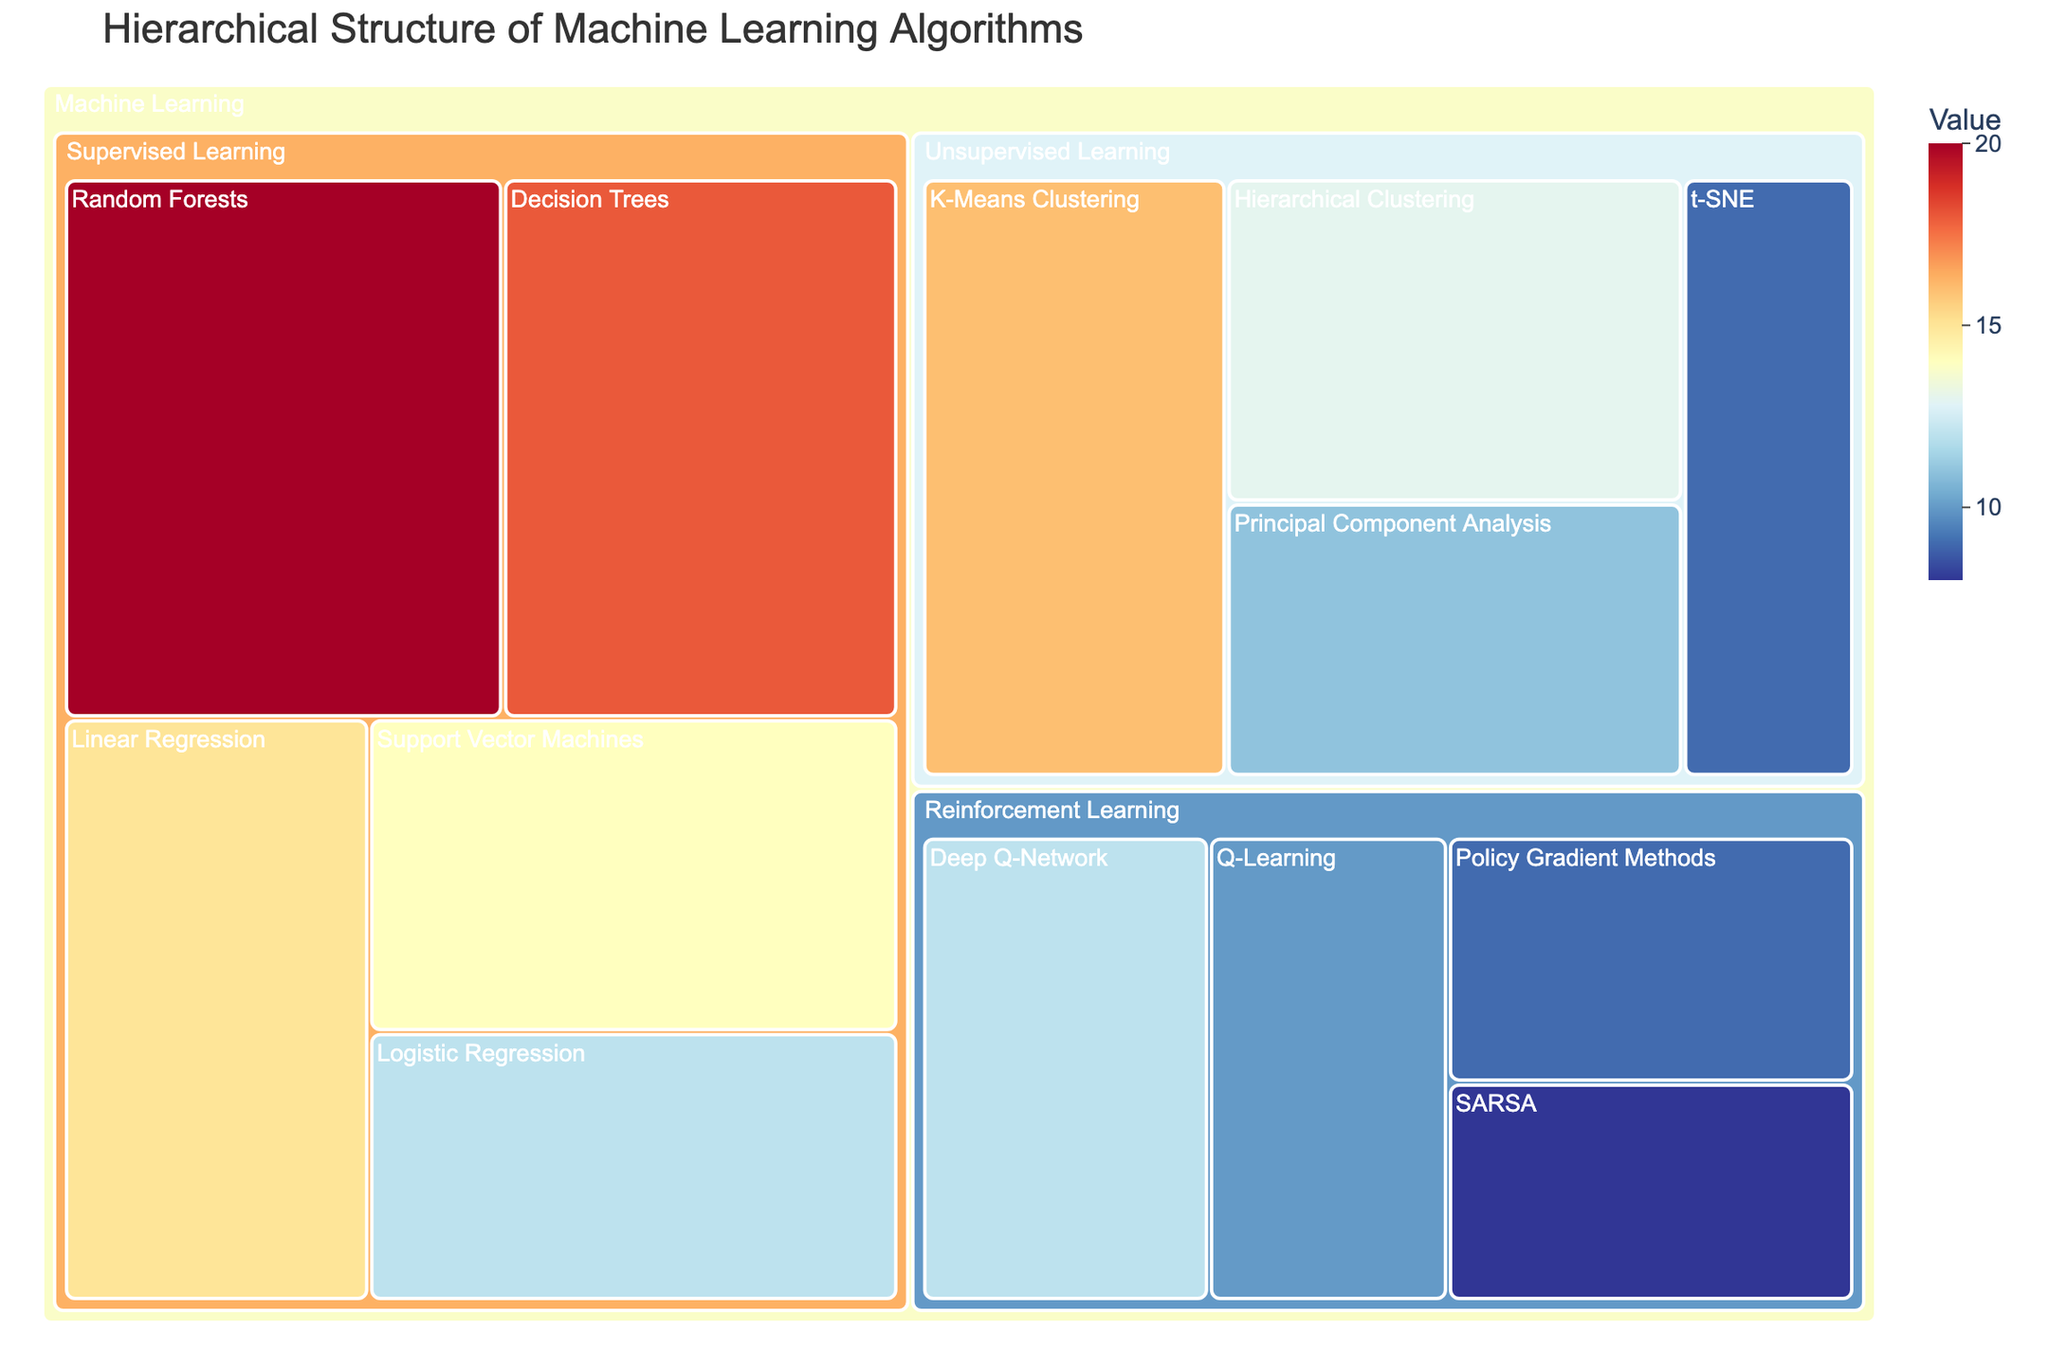what is the title of the treemap? The title is usually positioned at the top center of the plot and summarizes the data being visualized. In this case, the title is given in the code.
Answer: Hierarchical Structure of Machine Learning Algorithms How many algorithms are there in the Supervised Learning category? In the treemap, we can count the number of blocks within the Supervised Learning subcategory under Machine Learning. Each block represents an algorithm.
Answer: 5 Which subcategory has the algorithm with the highest value? To determine the highest value, we look for the largest block or the block with the highest value in the treemap and identify its parent subcategory. Random Forests in the Supervised Learning subcategory has the highest value of 20.
Answer: Supervised Learning What's the total value for all algorithms in the Unsupervised Learning category? Sum the values of all blocks under the Unsupervised Learning subcategory. The sum is \(16 + 13 + 11 + 9 = 49\).
Answer: 49 Is the value of Q-Learning higher than SARSA? Locate both Q-Learning and SARSA in the treemap and compare their values. Q-Learning has a value of 10, while SARSA has a value of 8.
Answer: Yes What is the average value of the algorithms in the Reinforcement Learning category? Sum the values of all algorithms in the Reinforcement Learning subcategory and divide by the number of algorithms (10 + 8 + 12 + 9) / 4. The sum is 39 and the count is 4. The average is 39 / 4 = 9.75.
Answer: 9.75 Which algorithm in the Unsupervised Learning category has the lowest value? Look for the smallest block in the Unsupervised Learning subcategory. t-SNE has the lowest value of 9.
Answer: t-SNE Between the categories of Supervised Learning and Reinforcement Learning, which has the larger total value? Sum the values for each subcategory. Supervised Learning: \(15+12+18+20+14 = 79\), Reinforcement Learning: \(10+8+12+9 = 39\). Compare both sums.
Answer: Supervised Learning 